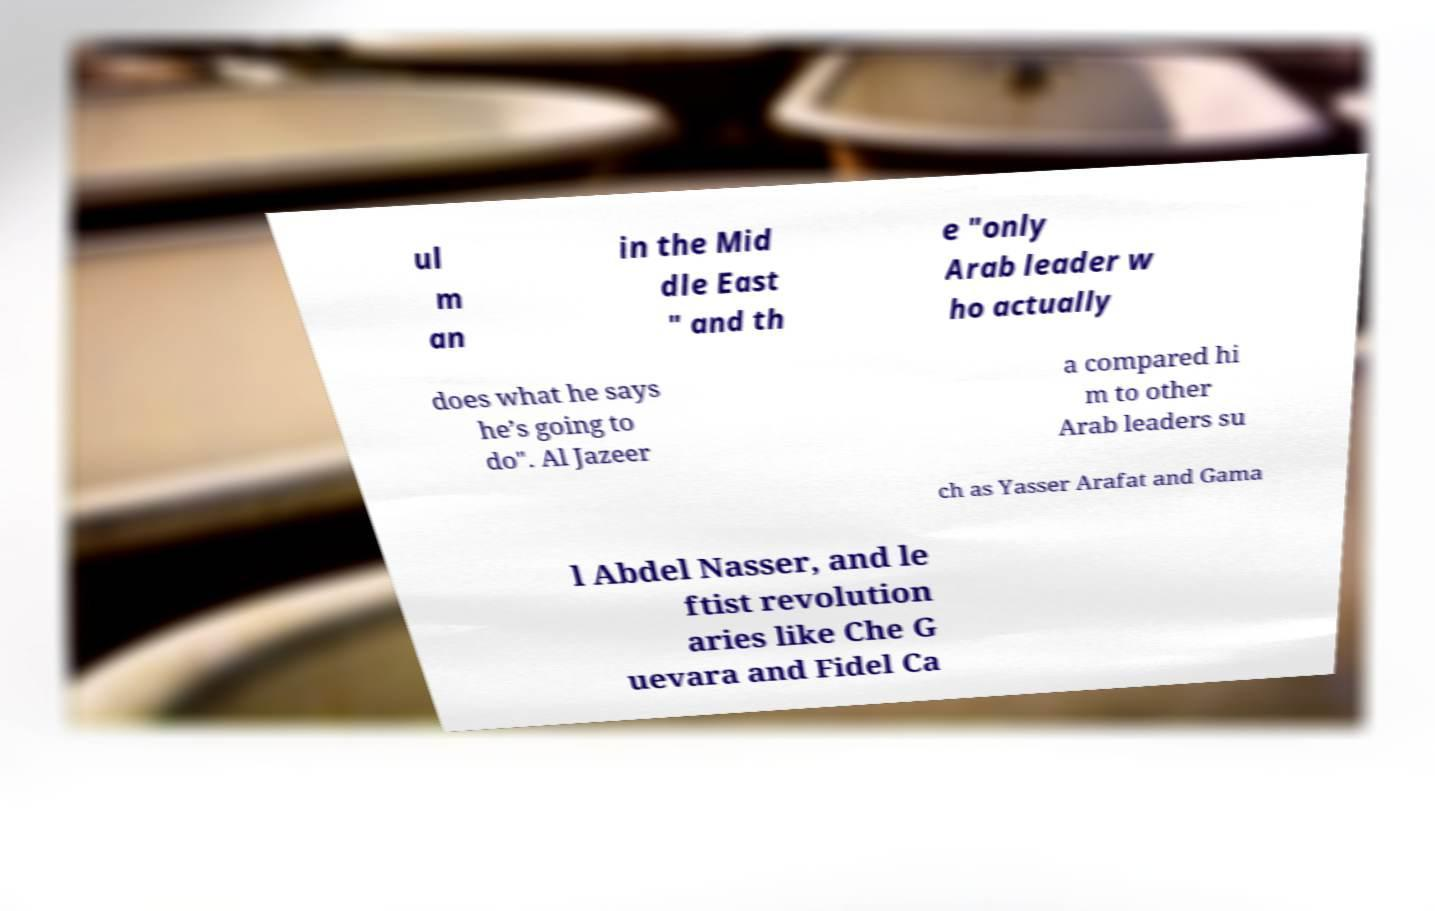For documentation purposes, I need the text within this image transcribed. Could you provide that? ul m an in the Mid dle East " and th e "only Arab leader w ho actually does what he says he’s going to do". Al Jazeer a compared hi m to other Arab leaders su ch as Yasser Arafat and Gama l Abdel Nasser, and le ftist revolution aries like Che G uevara and Fidel Ca 